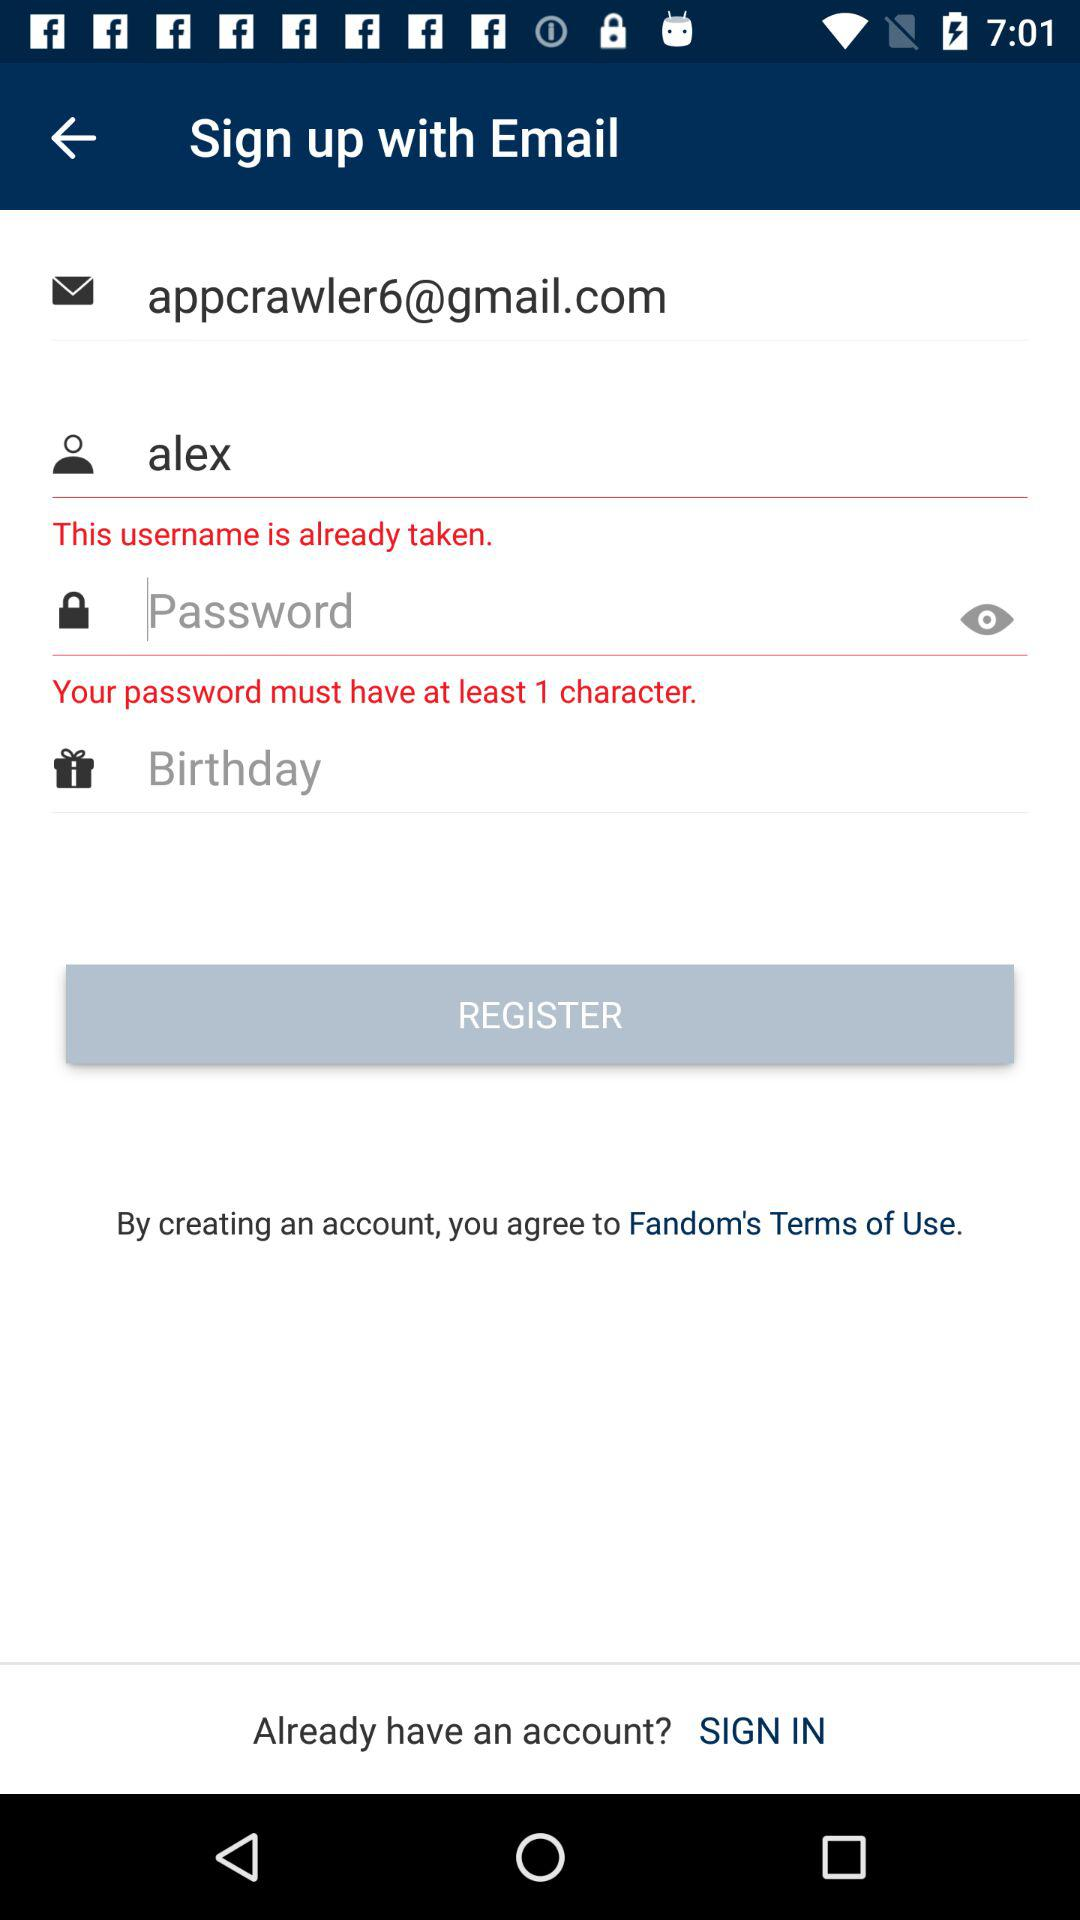What is the email address of the user? The email address is appcrawler6@gmail.com. 